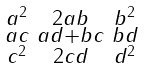Convert formula to latex. <formula><loc_0><loc_0><loc_500><loc_500>\begin{smallmatrix} a ^ { 2 } & 2 a b & b ^ { 2 } \\ a c & a d + b c & b d \\ c ^ { 2 } & 2 c d & d ^ { 2 } \end{smallmatrix}</formula> 